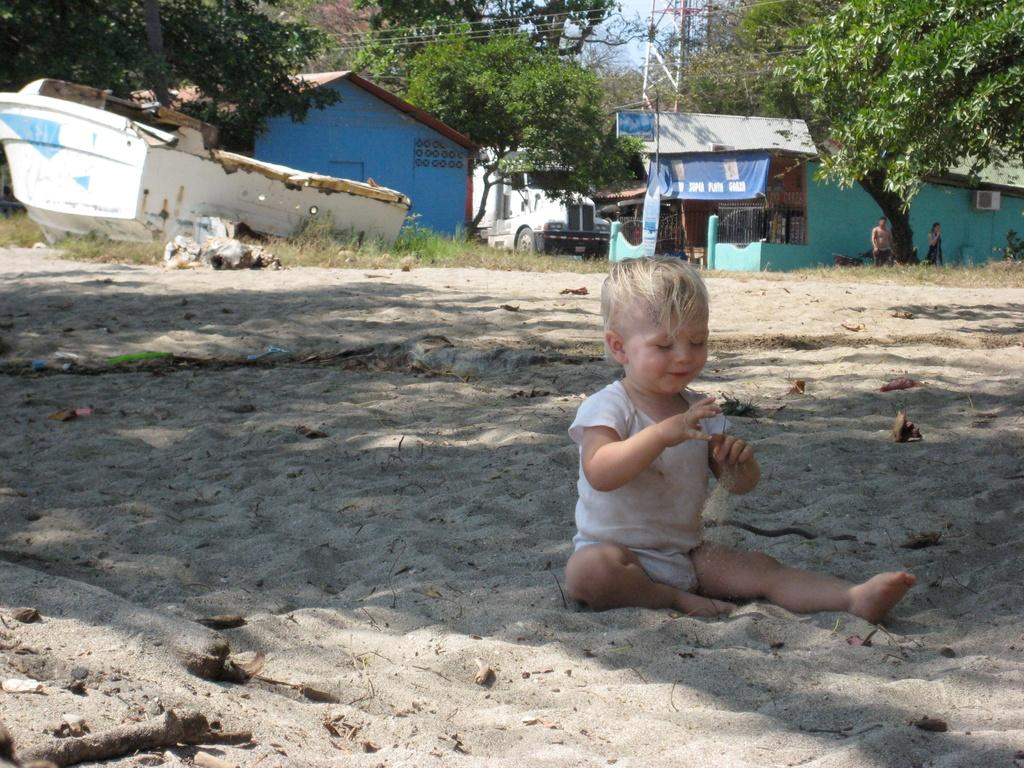What is the child doing in the image? The child is sitting on the sand. What can be seen in the background of the image? There is a vehicle, a boat, houses, trees, the sky, and people visible in the background. What type of terrain is visible in the image? There is grass visible in the image. What type of thrill ride can be seen in the image? There is no thrill ride present in the image; it features a child sitting on the sand and various background elements. How many bubbles are floating around the child in the image? There are no bubbles present in the image. 